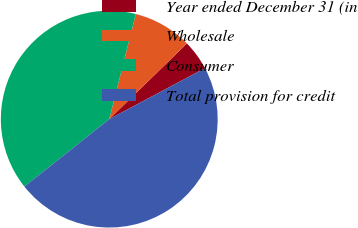<chart> <loc_0><loc_0><loc_500><loc_500><pie_chart><fcel>Year ended December 31 (in<fcel>Wholesale<fcel>Consumer<fcel>Total provision for credit<nl><fcel>4.51%<fcel>8.77%<fcel>39.63%<fcel>47.1%<nl></chart> 